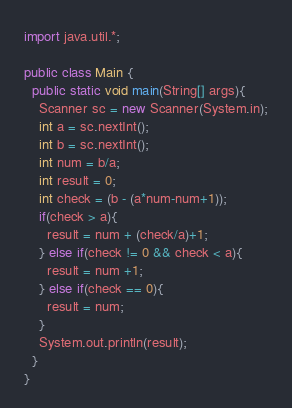Convert code to text. <code><loc_0><loc_0><loc_500><loc_500><_Java_>import java.util.*;

public class Main {
  public static void main(String[] args){
    Scanner sc = new Scanner(System.in);
    int a = sc.nextInt();
    int b = sc.nextInt();
    int num = b/a;
    int result = 0;
    int check = (b - (a*num-num+1));
    if(check > a){
      result = num + (check/a)+1;
    } else if(check != 0 && check < a){
      result = num +1;
    } else if(check == 0){
      result = num;
    }
    System.out.println(result);
  }
}</code> 